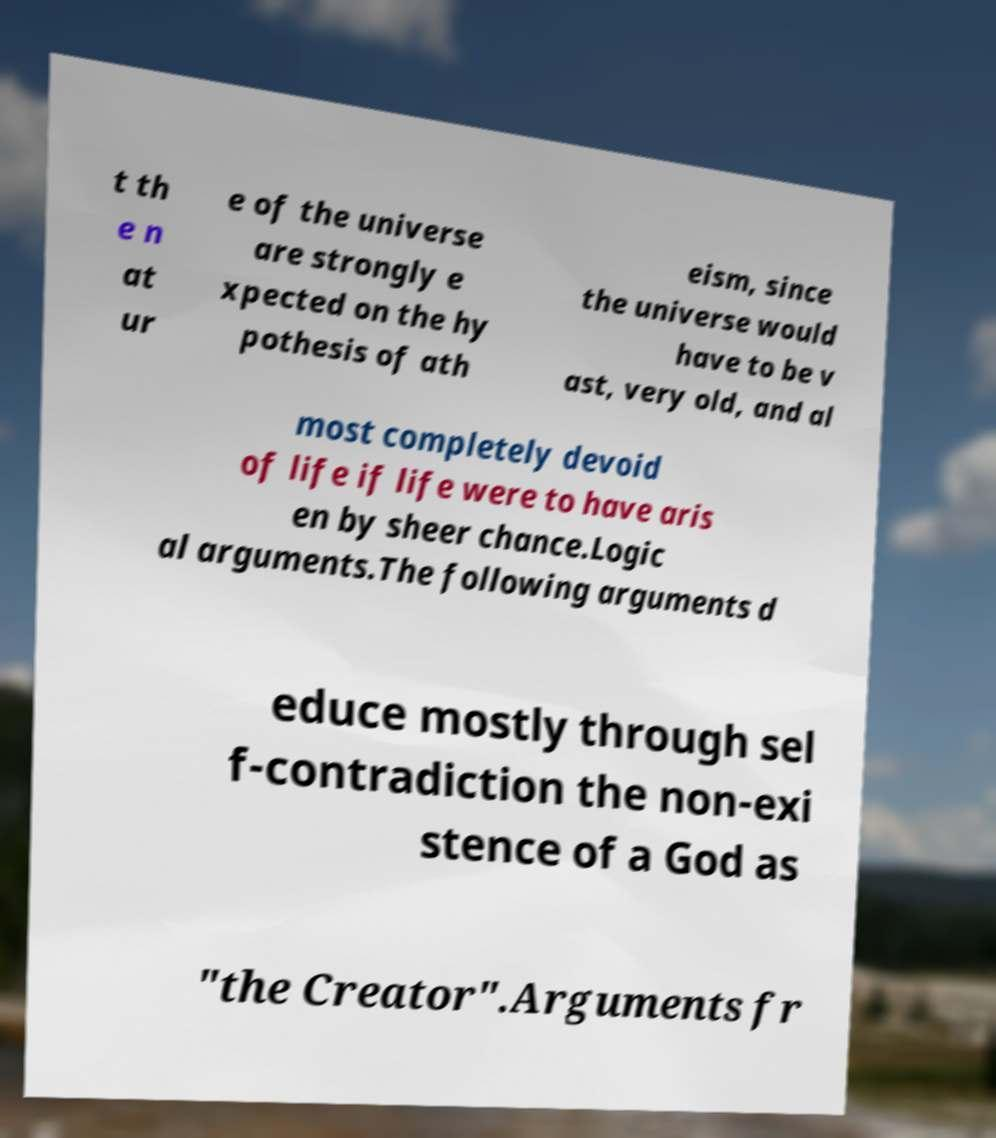Could you assist in decoding the text presented in this image and type it out clearly? t th e n at ur e of the universe are strongly e xpected on the hy pothesis of ath eism, since the universe would have to be v ast, very old, and al most completely devoid of life if life were to have aris en by sheer chance.Logic al arguments.The following arguments d educe mostly through sel f-contradiction the non-exi stence of a God as "the Creator".Arguments fr 